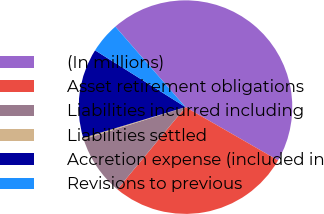<chart> <loc_0><loc_0><loc_500><loc_500><pie_chart><fcel>(In millions)<fcel>Asset retirement obligations<fcel>Liabilities incurred including<fcel>Liabilities settled<fcel>Accretion expense (included in<fcel>Revisions to previous<nl><fcel>44.71%<fcel>27.71%<fcel>9.12%<fcel>0.22%<fcel>13.57%<fcel>4.67%<nl></chart> 